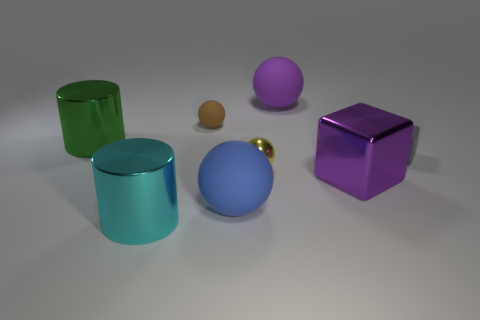Subtract all yellow balls. How many balls are left? 3 Subtract all cylinders. How many objects are left? 6 Add 1 tiny purple metal blocks. How many objects exist? 9 Subtract all gray blocks. How many blocks are left? 1 Subtract all blue cylinders. Subtract all purple spheres. How many cylinders are left? 2 Subtract all large cyan shiny blocks. Subtract all yellow objects. How many objects are left? 7 Add 5 large purple metal things. How many large purple metal things are left? 6 Add 1 purple metallic objects. How many purple metallic objects exist? 2 Subtract 1 purple balls. How many objects are left? 7 Subtract 1 cylinders. How many cylinders are left? 1 